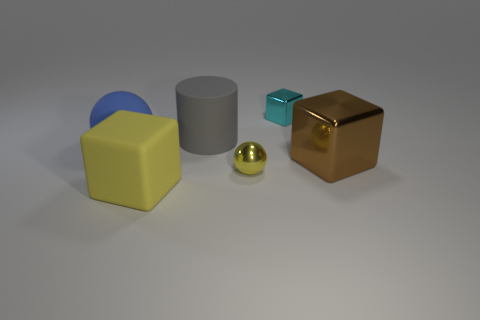Is there anything else that has the same size as the blue matte sphere?
Keep it short and to the point. Yes. What number of objects are either metal objects that are to the right of the small cyan cube or brown shiny cubes?
Ensure brevity in your answer.  1. There is a shiny block that is in front of the blue rubber object; is its size the same as the big yellow matte block?
Your response must be concise. Yes. Is the number of large yellow rubber things that are in front of the big gray rubber thing less than the number of large blue spheres?
Offer a terse response. No. There is a gray object that is the same size as the brown cube; what is it made of?
Your response must be concise. Rubber. What number of big objects are either yellow objects or gray cylinders?
Give a very brief answer. 2. What number of things are spheres that are left of the matte cube or yellow objects behind the yellow rubber cube?
Your response must be concise. 2. Is the number of spheres less than the number of blue rubber things?
Provide a short and direct response. No. There is a brown metallic thing that is the same size as the gray rubber cylinder; what shape is it?
Make the answer very short. Cube. What number of other objects are the same color as the tiny metallic cube?
Make the answer very short. 0. 